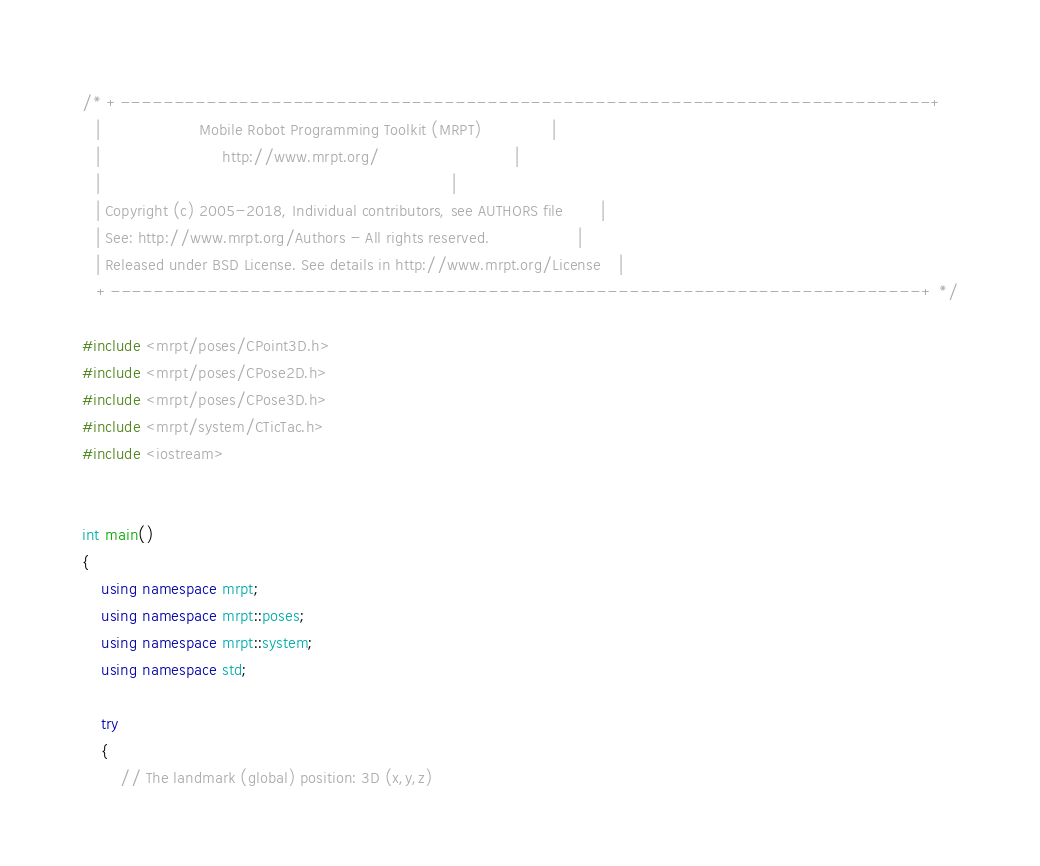Convert code to text. <code><loc_0><loc_0><loc_500><loc_500><_C++_>/* +---------------------------------------------------------------------------+
   |                     Mobile Robot Programming Toolkit (MRPT)               |
   |                          http://www.mrpt.org/                             |
   |                                                                           |
   | Copyright (c) 2005-2018, Individual contributors, see AUTHORS file        |
   | See: http://www.mrpt.org/Authors - All rights reserved.                   |
   | Released under BSD License. See details in http://www.mrpt.org/License    |
   +---------------------------------------------------------------------------+ */

#include <mrpt/poses/CPoint3D.h>
#include <mrpt/poses/CPose2D.h>
#include <mrpt/poses/CPose3D.h>
#include <mrpt/system/CTicTac.h>
#include <iostream>


int main()
{
	using namespace mrpt;
	using namespace mrpt::poses;
	using namespace mrpt::system;
	using namespace std;

	try
	{
		// The landmark (global) position: 3D (x,y,z)</code> 